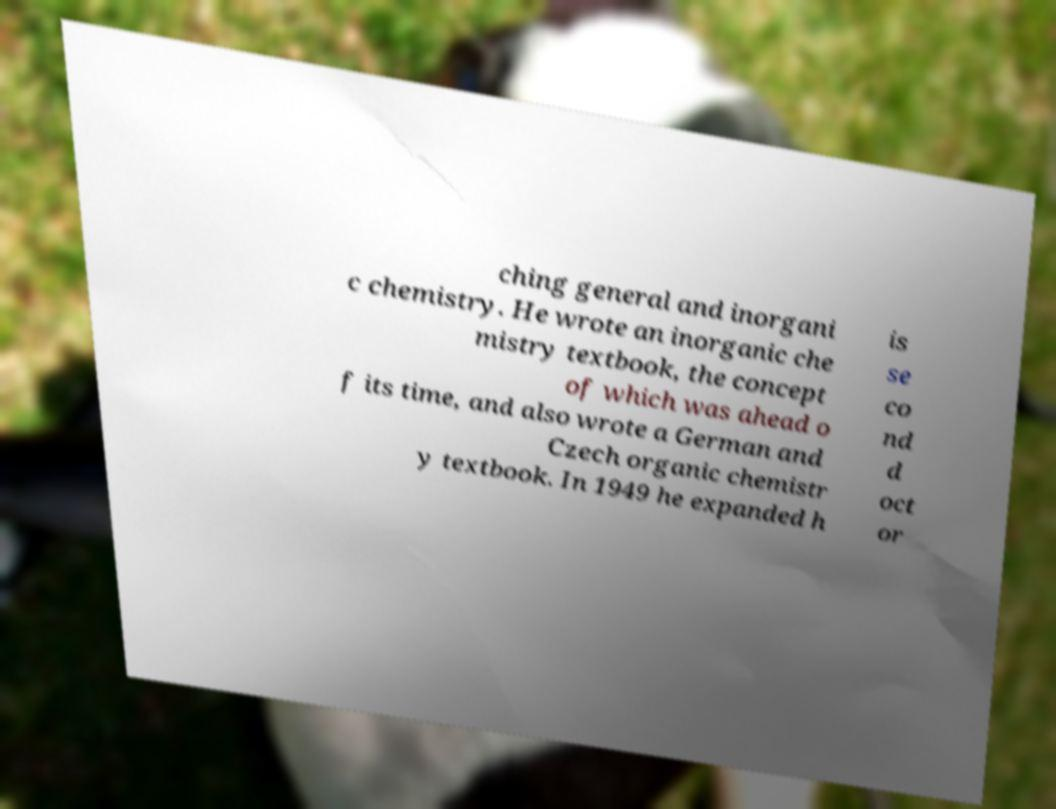For documentation purposes, I need the text within this image transcribed. Could you provide that? ching general and inorgani c chemistry. He wrote an inorganic che mistry textbook, the concept of which was ahead o f its time, and also wrote a German and Czech organic chemistr y textbook. In 1949 he expanded h is se co nd d oct or 